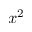<formula> <loc_0><loc_0><loc_500><loc_500>x ^ { 2 }</formula> 